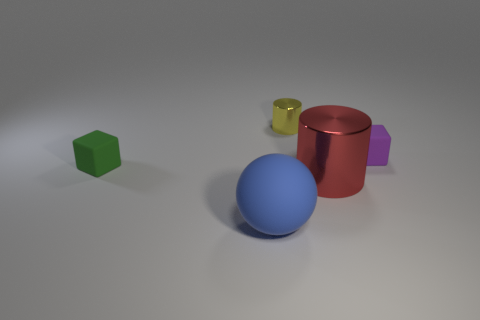Add 1 small red matte things. How many objects exist? 6 Subtract 0 purple balls. How many objects are left? 5 Subtract all balls. How many objects are left? 4 Subtract 1 blocks. How many blocks are left? 1 Subtract all cyan blocks. Subtract all cyan spheres. How many blocks are left? 2 Subtract all cyan balls. How many yellow blocks are left? 0 Subtract all tiny yellow metallic cylinders. Subtract all green blocks. How many objects are left? 3 Add 3 red cylinders. How many red cylinders are left? 4 Add 2 small green cubes. How many small green cubes exist? 3 